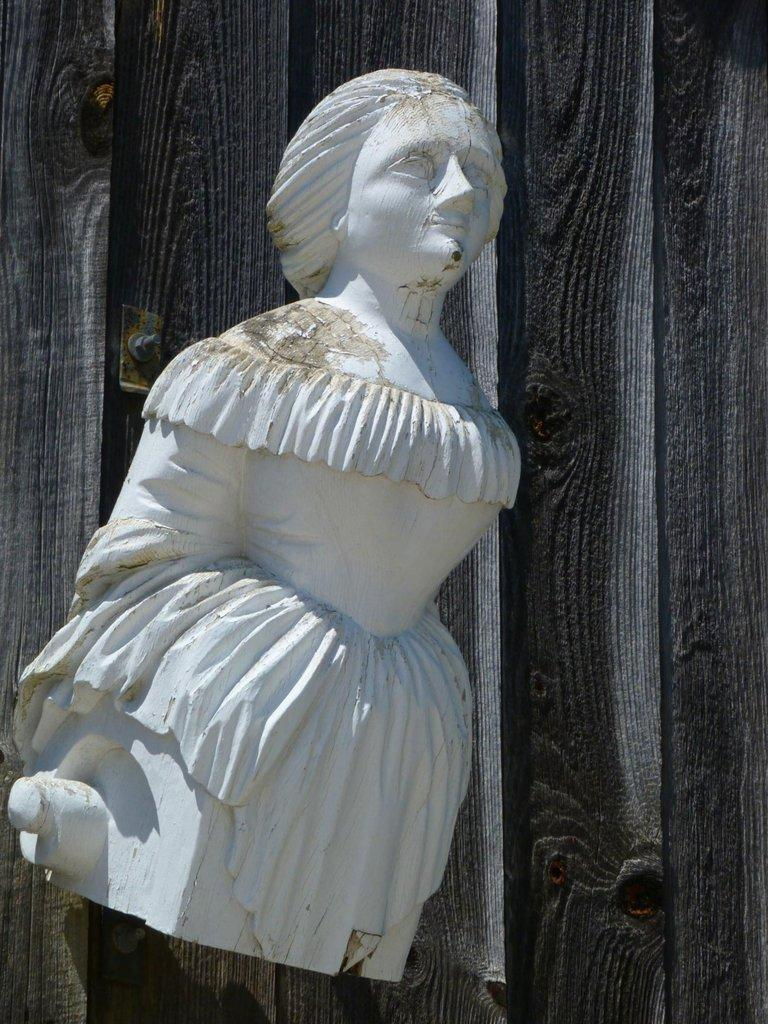What is the main subject of the image? There is a statue in the image. What is the color of the statue? The statue is white in color. What is the statue attached to? The statue is attached to a wooden wall. Where is the tree located in the image? There is no tree present in the image; it only features a statue attached to a wooden wall. What type of lunchroom can be seen in the image? There is no lunchroom present in the image; it only features a statue attached to a wooden wall. 